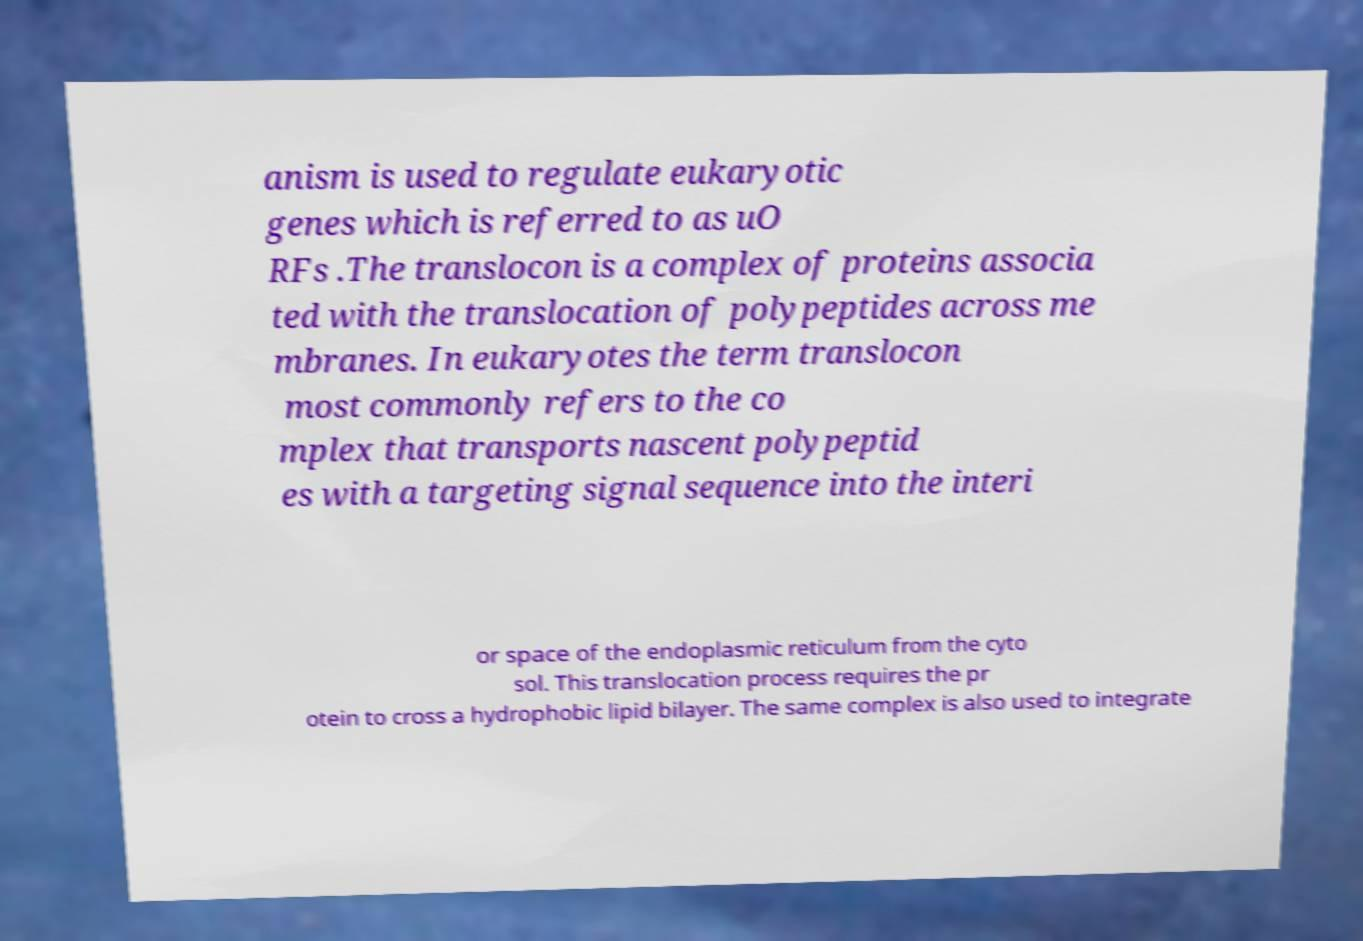Could you extract and type out the text from this image? anism is used to regulate eukaryotic genes which is referred to as uO RFs .The translocon is a complex of proteins associa ted with the translocation of polypeptides across me mbranes. In eukaryotes the term translocon most commonly refers to the co mplex that transports nascent polypeptid es with a targeting signal sequence into the interi or space of the endoplasmic reticulum from the cyto sol. This translocation process requires the pr otein to cross a hydrophobic lipid bilayer. The same complex is also used to integrate 